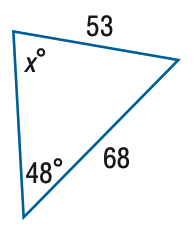Answer the mathemtical geometry problem and directly provide the correct option letter.
Question: Find x. Round the angle measure to the nearest degree.
Choices: A: 68 B: 72 C: 76 D: 80 B 